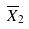<formula> <loc_0><loc_0><loc_500><loc_500>\overline { X } _ { 2 }</formula> 